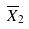<formula> <loc_0><loc_0><loc_500><loc_500>\overline { X } _ { 2 }</formula> 